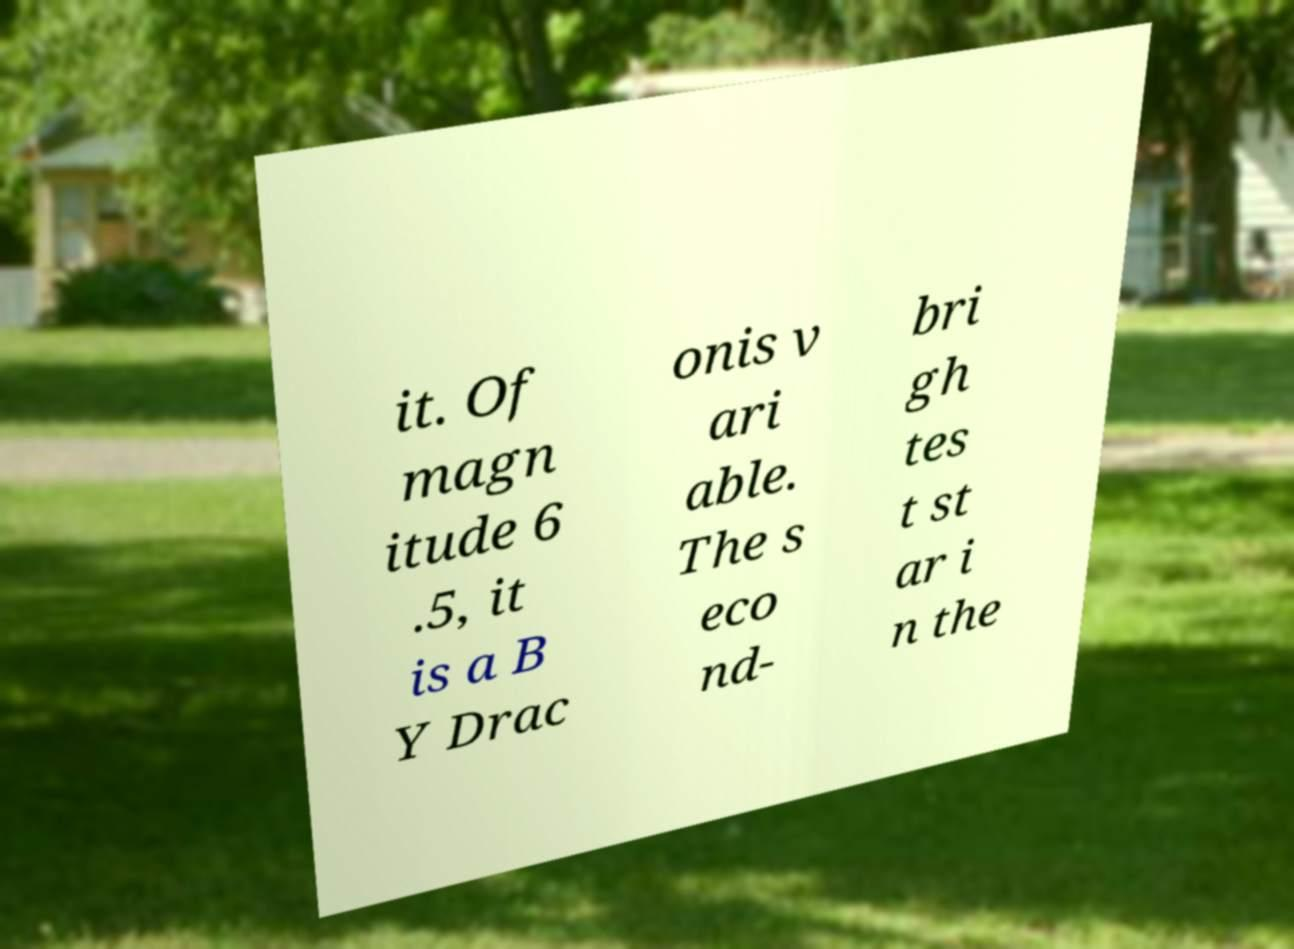For documentation purposes, I need the text within this image transcribed. Could you provide that? it. Of magn itude 6 .5, it is a B Y Drac onis v ari able. The s eco nd- bri gh tes t st ar i n the 